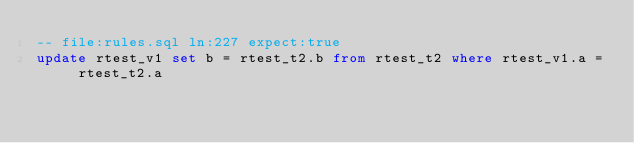<code> <loc_0><loc_0><loc_500><loc_500><_SQL_>-- file:rules.sql ln:227 expect:true
update rtest_v1 set b = rtest_t2.b from rtest_t2 where rtest_v1.a = rtest_t2.a
</code> 